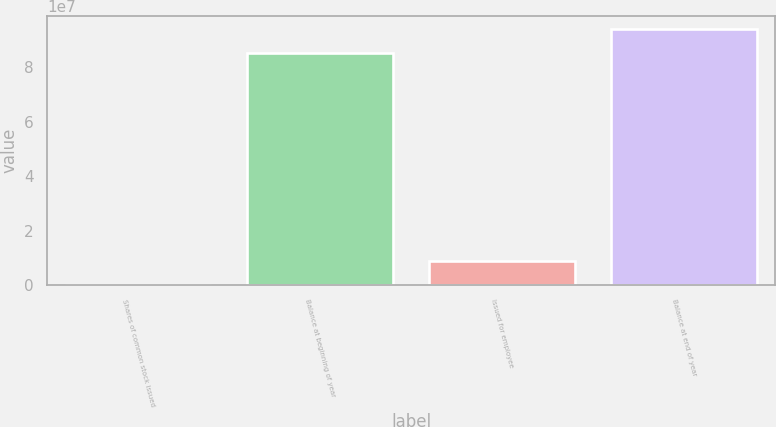Convert chart to OTSL. <chart><loc_0><loc_0><loc_500><loc_500><bar_chart><fcel>Shares of common stock issued<fcel>Balance at beginning of year<fcel>Issued for employee<fcel>Balance at end of year<nl><fcel>2004<fcel>8.52965e+07<fcel>8.72755e+06<fcel>9.4022e+07<nl></chart> 